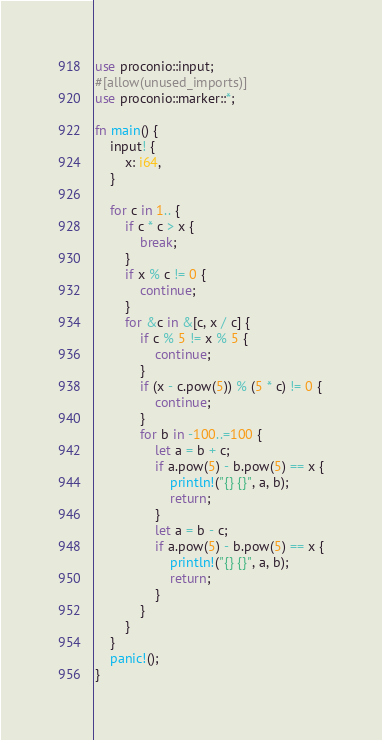<code> <loc_0><loc_0><loc_500><loc_500><_Rust_>use proconio::input;
#[allow(unused_imports)]
use proconio::marker::*;

fn main() {
    input! {
        x: i64,
    }

    for c in 1.. {
        if c * c > x {
            break;
        }
        if x % c != 0 {
            continue;
        }
        for &c in &[c, x / c] {
            if c % 5 != x % 5 {
                continue;
            }
            if (x - c.pow(5)) % (5 * c) != 0 {
                continue;
            }
            for b in -100..=100 {
                let a = b + c;
                if a.pow(5) - b.pow(5) == x {
                    println!("{} {}", a, b);
                    return;
                }
                let a = b - c;
                if a.pow(5) - b.pow(5) == x {
                    println!("{} {}", a, b);
                    return;
                }
            }
        }
    }
    panic!();
}
</code> 